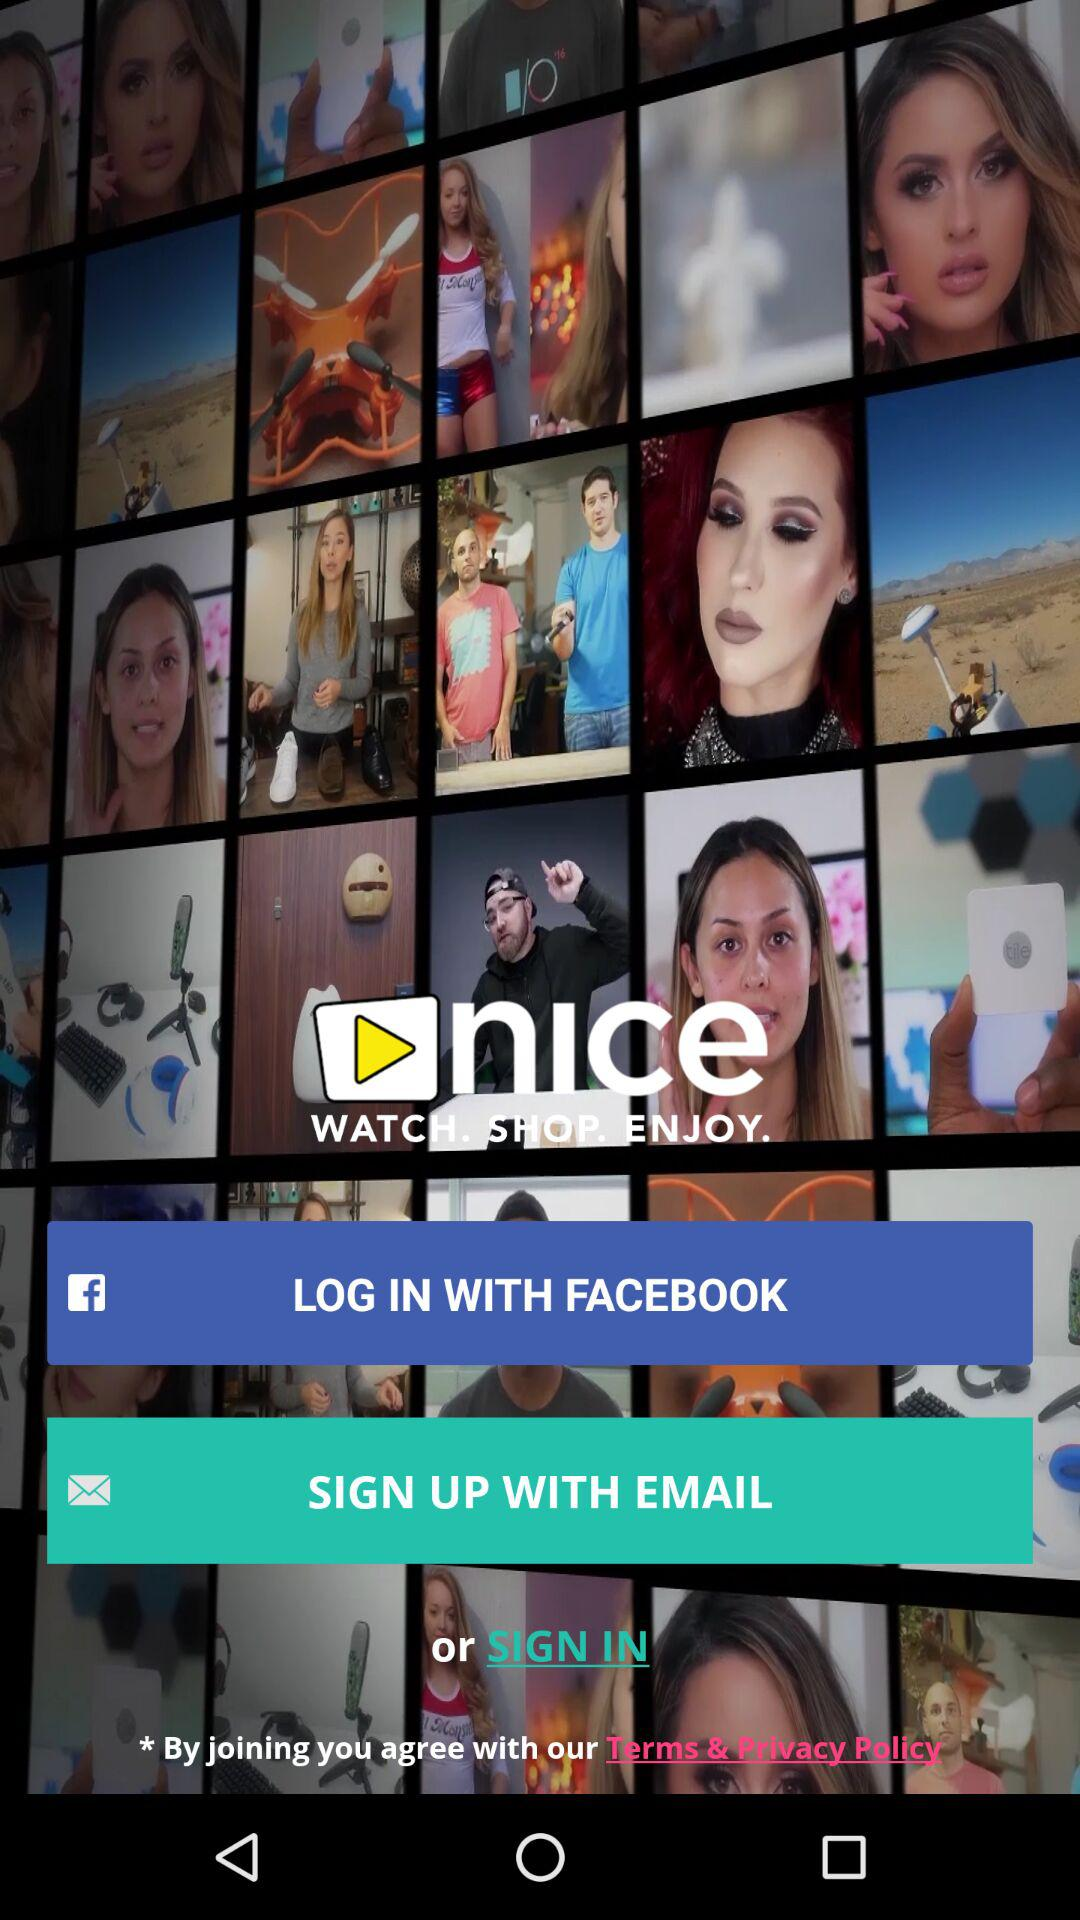How long does it take to log in with "FACEBOOK"?
When the provided information is insufficient, respond with <no answer>. <no answer> 